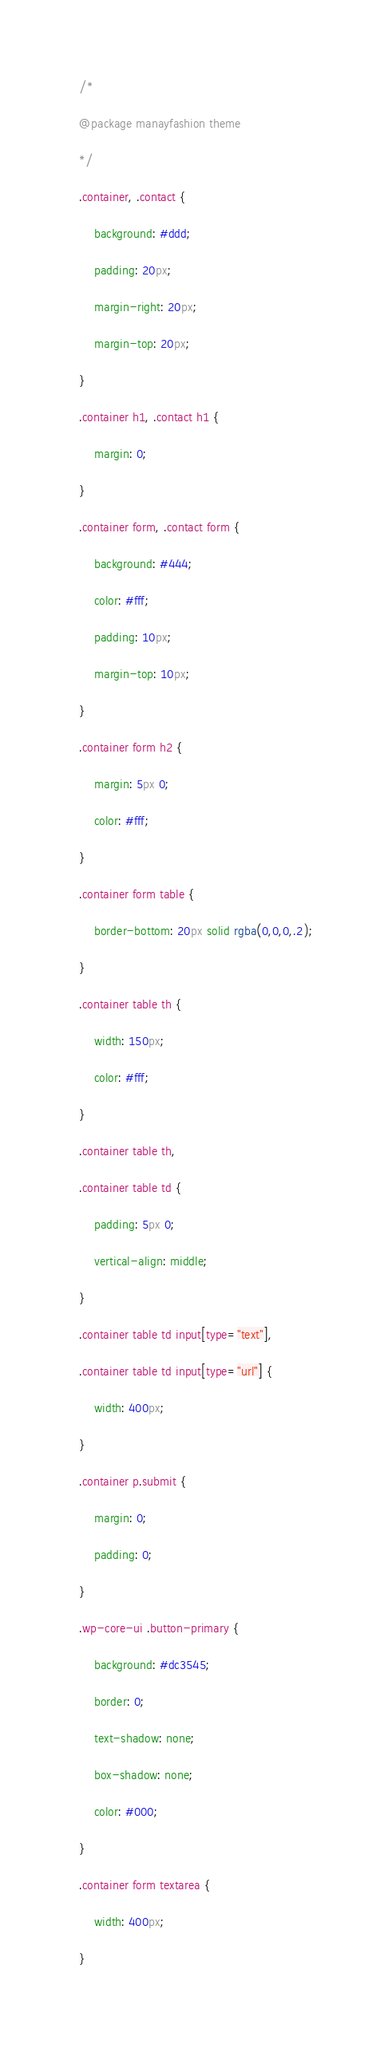Convert code to text. <code><loc_0><loc_0><loc_500><loc_500><_CSS_>/*
@package manayfashion theme
*/
.container, .contact {
    background: #ddd;
    padding: 20px;
    margin-right: 20px;
    margin-top: 20px;
}
.container h1, .contact h1 {
    margin: 0;
}
.container form, .contact form {
    background: #444;
    color: #fff;
    padding: 10px;
    margin-top: 10px;
}
.container form h2 {
    margin: 5px 0;
    color: #fff;
}
.container form table {
    border-bottom: 20px solid rgba(0,0,0,.2);
}
.container table th {
    width: 150px;
    color: #fff;
}
.container table th, 
.container table td {
    padding: 5px 0;
    vertical-align: middle;
}
.container table td input[type="text"],
.container table td input[type="url"] {
    width: 400px;
}
.container p.submit {
    margin: 0;
    padding: 0;
}
.wp-core-ui .button-primary {
    background: #dc3545;
    border: 0;
    text-shadow: none;
    box-shadow: none;
    color: #000;
}
.container form textarea {
    width: 400px;
}</code> 